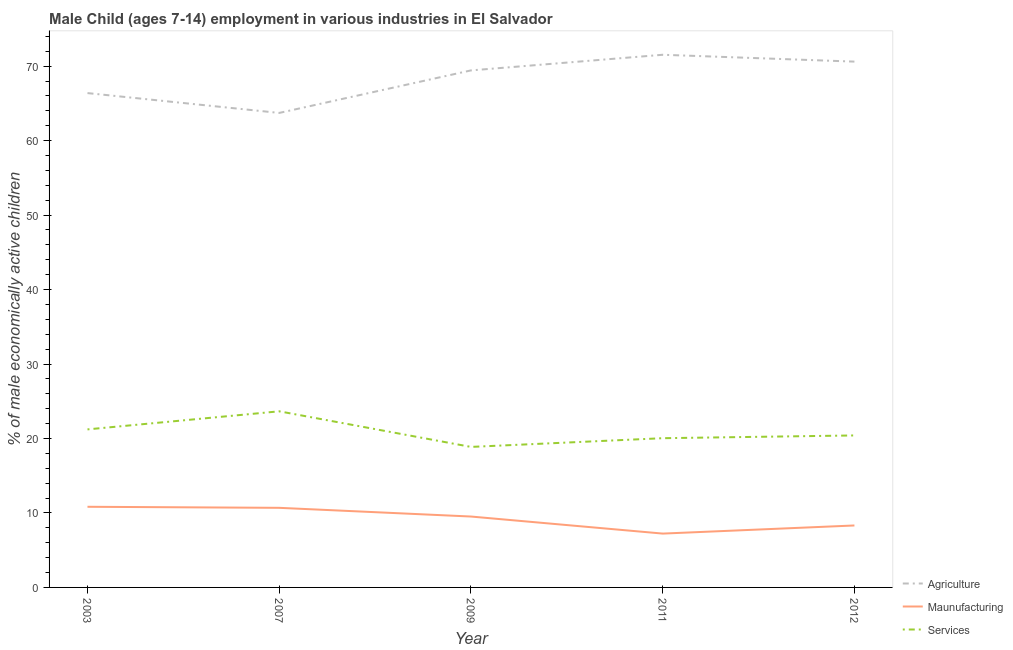How many different coloured lines are there?
Ensure brevity in your answer.  3. Does the line corresponding to percentage of economically active children in services intersect with the line corresponding to percentage of economically active children in manufacturing?
Provide a short and direct response. No. What is the percentage of economically active children in agriculture in 2009?
Your answer should be very brief. 69.43. Across all years, what is the maximum percentage of economically active children in manufacturing?
Your answer should be compact. 10.83. Across all years, what is the minimum percentage of economically active children in services?
Your answer should be very brief. 18.87. In which year was the percentage of economically active children in agriculture maximum?
Your answer should be very brief. 2011. What is the total percentage of economically active children in services in the graph?
Make the answer very short. 104.19. What is the difference between the percentage of economically active children in manufacturing in 2011 and that in 2012?
Offer a very short reply. -1.09. What is the difference between the percentage of economically active children in agriculture in 2012 and the percentage of economically active children in manufacturing in 2011?
Make the answer very short. 63.38. What is the average percentage of economically active children in services per year?
Give a very brief answer. 20.84. In the year 2011, what is the difference between the percentage of economically active children in services and percentage of economically active children in manufacturing?
Ensure brevity in your answer.  12.81. In how many years, is the percentage of economically active children in manufacturing greater than 12 %?
Keep it short and to the point. 0. What is the ratio of the percentage of economically active children in agriculture in 2003 to that in 2012?
Provide a succinct answer. 0.94. Is the difference between the percentage of economically active children in services in 2007 and 2011 greater than the difference between the percentage of economically active children in manufacturing in 2007 and 2011?
Give a very brief answer. Yes. What is the difference between the highest and the second highest percentage of economically active children in manufacturing?
Your answer should be compact. 0.14. What is the difference between the highest and the lowest percentage of economically active children in agriculture?
Keep it short and to the point. 7.81. In how many years, is the percentage of economically active children in services greater than the average percentage of economically active children in services taken over all years?
Your answer should be compact. 2. Does the percentage of economically active children in manufacturing monotonically increase over the years?
Your response must be concise. No. How many years are there in the graph?
Your response must be concise. 5. What is the difference between two consecutive major ticks on the Y-axis?
Provide a short and direct response. 10. Does the graph contain any zero values?
Your answer should be very brief. No. How many legend labels are there?
Your answer should be compact. 3. How are the legend labels stacked?
Your response must be concise. Vertical. What is the title of the graph?
Your response must be concise. Male Child (ages 7-14) employment in various industries in El Salvador. Does "Labor Market" appear as one of the legend labels in the graph?
Your answer should be very brief. No. What is the label or title of the Y-axis?
Make the answer very short. % of male economically active children. What is the % of male economically active children in Agriculture in 2003?
Ensure brevity in your answer.  66.38. What is the % of male economically active children in Maunufacturing in 2003?
Offer a very short reply. 10.83. What is the % of male economically active children of Services in 2003?
Offer a very short reply. 21.22. What is the % of male economically active children in Agriculture in 2007?
Provide a short and direct response. 63.72. What is the % of male economically active children in Maunufacturing in 2007?
Give a very brief answer. 10.69. What is the % of male economically active children in Services in 2007?
Provide a short and direct response. 23.65. What is the % of male economically active children in Agriculture in 2009?
Your answer should be very brief. 69.43. What is the % of male economically active children of Maunufacturing in 2009?
Provide a succinct answer. 9.52. What is the % of male economically active children of Services in 2009?
Give a very brief answer. 18.87. What is the % of male economically active children in Agriculture in 2011?
Your answer should be very brief. 71.53. What is the % of male economically active children in Maunufacturing in 2011?
Your answer should be compact. 7.23. What is the % of male economically active children of Services in 2011?
Your response must be concise. 20.04. What is the % of male economically active children in Agriculture in 2012?
Offer a terse response. 70.61. What is the % of male economically active children of Maunufacturing in 2012?
Offer a very short reply. 8.32. What is the % of male economically active children of Services in 2012?
Your answer should be very brief. 20.41. Across all years, what is the maximum % of male economically active children of Agriculture?
Make the answer very short. 71.53. Across all years, what is the maximum % of male economically active children of Maunufacturing?
Provide a succinct answer. 10.83. Across all years, what is the maximum % of male economically active children of Services?
Your answer should be very brief. 23.65. Across all years, what is the minimum % of male economically active children of Agriculture?
Give a very brief answer. 63.72. Across all years, what is the minimum % of male economically active children of Maunufacturing?
Keep it short and to the point. 7.23. Across all years, what is the minimum % of male economically active children of Services?
Your answer should be very brief. 18.87. What is the total % of male economically active children of Agriculture in the graph?
Make the answer very short. 341.67. What is the total % of male economically active children of Maunufacturing in the graph?
Your response must be concise. 46.59. What is the total % of male economically active children of Services in the graph?
Make the answer very short. 104.19. What is the difference between the % of male economically active children of Agriculture in 2003 and that in 2007?
Offer a very short reply. 2.66. What is the difference between the % of male economically active children of Maunufacturing in 2003 and that in 2007?
Make the answer very short. 0.14. What is the difference between the % of male economically active children of Services in 2003 and that in 2007?
Make the answer very short. -2.43. What is the difference between the % of male economically active children of Agriculture in 2003 and that in 2009?
Provide a short and direct response. -3.05. What is the difference between the % of male economically active children in Maunufacturing in 2003 and that in 2009?
Provide a short and direct response. 1.31. What is the difference between the % of male economically active children of Services in 2003 and that in 2009?
Give a very brief answer. 2.35. What is the difference between the % of male economically active children of Agriculture in 2003 and that in 2011?
Provide a short and direct response. -5.15. What is the difference between the % of male economically active children of Maunufacturing in 2003 and that in 2011?
Provide a succinct answer. 3.6. What is the difference between the % of male economically active children of Services in 2003 and that in 2011?
Offer a terse response. 1.18. What is the difference between the % of male economically active children in Agriculture in 2003 and that in 2012?
Your response must be concise. -4.23. What is the difference between the % of male economically active children of Maunufacturing in 2003 and that in 2012?
Make the answer very short. 2.51. What is the difference between the % of male economically active children of Services in 2003 and that in 2012?
Provide a succinct answer. 0.81. What is the difference between the % of male economically active children in Agriculture in 2007 and that in 2009?
Keep it short and to the point. -5.71. What is the difference between the % of male economically active children in Maunufacturing in 2007 and that in 2009?
Provide a short and direct response. 1.17. What is the difference between the % of male economically active children of Services in 2007 and that in 2009?
Ensure brevity in your answer.  4.78. What is the difference between the % of male economically active children in Agriculture in 2007 and that in 2011?
Offer a very short reply. -7.81. What is the difference between the % of male economically active children in Maunufacturing in 2007 and that in 2011?
Your response must be concise. 3.46. What is the difference between the % of male economically active children of Services in 2007 and that in 2011?
Your answer should be compact. 3.61. What is the difference between the % of male economically active children of Agriculture in 2007 and that in 2012?
Your answer should be compact. -6.89. What is the difference between the % of male economically active children of Maunufacturing in 2007 and that in 2012?
Provide a succinct answer. 2.37. What is the difference between the % of male economically active children in Services in 2007 and that in 2012?
Offer a very short reply. 3.24. What is the difference between the % of male economically active children of Agriculture in 2009 and that in 2011?
Make the answer very short. -2.1. What is the difference between the % of male economically active children of Maunufacturing in 2009 and that in 2011?
Keep it short and to the point. 2.29. What is the difference between the % of male economically active children of Services in 2009 and that in 2011?
Provide a succinct answer. -1.17. What is the difference between the % of male economically active children in Agriculture in 2009 and that in 2012?
Provide a succinct answer. -1.18. What is the difference between the % of male economically active children in Services in 2009 and that in 2012?
Provide a short and direct response. -1.54. What is the difference between the % of male economically active children of Agriculture in 2011 and that in 2012?
Ensure brevity in your answer.  0.92. What is the difference between the % of male economically active children of Maunufacturing in 2011 and that in 2012?
Keep it short and to the point. -1.09. What is the difference between the % of male economically active children of Services in 2011 and that in 2012?
Make the answer very short. -0.37. What is the difference between the % of male economically active children of Agriculture in 2003 and the % of male economically active children of Maunufacturing in 2007?
Give a very brief answer. 55.69. What is the difference between the % of male economically active children of Agriculture in 2003 and the % of male economically active children of Services in 2007?
Provide a short and direct response. 42.73. What is the difference between the % of male economically active children in Maunufacturing in 2003 and the % of male economically active children in Services in 2007?
Offer a very short reply. -12.82. What is the difference between the % of male economically active children of Agriculture in 2003 and the % of male economically active children of Maunufacturing in 2009?
Offer a terse response. 56.86. What is the difference between the % of male economically active children of Agriculture in 2003 and the % of male economically active children of Services in 2009?
Ensure brevity in your answer.  47.51. What is the difference between the % of male economically active children of Maunufacturing in 2003 and the % of male economically active children of Services in 2009?
Offer a very short reply. -8.04. What is the difference between the % of male economically active children in Agriculture in 2003 and the % of male economically active children in Maunufacturing in 2011?
Your answer should be very brief. 59.15. What is the difference between the % of male economically active children of Agriculture in 2003 and the % of male economically active children of Services in 2011?
Your response must be concise. 46.34. What is the difference between the % of male economically active children in Maunufacturing in 2003 and the % of male economically active children in Services in 2011?
Your response must be concise. -9.21. What is the difference between the % of male economically active children of Agriculture in 2003 and the % of male economically active children of Maunufacturing in 2012?
Give a very brief answer. 58.06. What is the difference between the % of male economically active children of Agriculture in 2003 and the % of male economically active children of Services in 2012?
Your response must be concise. 45.97. What is the difference between the % of male economically active children in Maunufacturing in 2003 and the % of male economically active children in Services in 2012?
Offer a very short reply. -9.58. What is the difference between the % of male economically active children of Agriculture in 2007 and the % of male economically active children of Maunufacturing in 2009?
Make the answer very short. 54.2. What is the difference between the % of male economically active children of Agriculture in 2007 and the % of male economically active children of Services in 2009?
Provide a short and direct response. 44.85. What is the difference between the % of male economically active children in Maunufacturing in 2007 and the % of male economically active children in Services in 2009?
Provide a succinct answer. -8.18. What is the difference between the % of male economically active children in Agriculture in 2007 and the % of male economically active children in Maunufacturing in 2011?
Your answer should be compact. 56.49. What is the difference between the % of male economically active children of Agriculture in 2007 and the % of male economically active children of Services in 2011?
Provide a short and direct response. 43.68. What is the difference between the % of male economically active children of Maunufacturing in 2007 and the % of male economically active children of Services in 2011?
Make the answer very short. -9.35. What is the difference between the % of male economically active children in Agriculture in 2007 and the % of male economically active children in Maunufacturing in 2012?
Make the answer very short. 55.4. What is the difference between the % of male economically active children of Agriculture in 2007 and the % of male economically active children of Services in 2012?
Ensure brevity in your answer.  43.31. What is the difference between the % of male economically active children in Maunufacturing in 2007 and the % of male economically active children in Services in 2012?
Your answer should be compact. -9.72. What is the difference between the % of male economically active children in Agriculture in 2009 and the % of male economically active children in Maunufacturing in 2011?
Keep it short and to the point. 62.2. What is the difference between the % of male economically active children of Agriculture in 2009 and the % of male economically active children of Services in 2011?
Offer a terse response. 49.39. What is the difference between the % of male economically active children of Maunufacturing in 2009 and the % of male economically active children of Services in 2011?
Ensure brevity in your answer.  -10.52. What is the difference between the % of male economically active children of Agriculture in 2009 and the % of male economically active children of Maunufacturing in 2012?
Offer a terse response. 61.11. What is the difference between the % of male economically active children in Agriculture in 2009 and the % of male economically active children in Services in 2012?
Offer a very short reply. 49.02. What is the difference between the % of male economically active children of Maunufacturing in 2009 and the % of male economically active children of Services in 2012?
Ensure brevity in your answer.  -10.89. What is the difference between the % of male economically active children of Agriculture in 2011 and the % of male economically active children of Maunufacturing in 2012?
Offer a very short reply. 63.21. What is the difference between the % of male economically active children of Agriculture in 2011 and the % of male economically active children of Services in 2012?
Offer a terse response. 51.12. What is the difference between the % of male economically active children in Maunufacturing in 2011 and the % of male economically active children in Services in 2012?
Provide a short and direct response. -13.18. What is the average % of male economically active children of Agriculture per year?
Your answer should be very brief. 68.33. What is the average % of male economically active children of Maunufacturing per year?
Your answer should be compact. 9.32. What is the average % of male economically active children in Services per year?
Provide a short and direct response. 20.84. In the year 2003, what is the difference between the % of male economically active children in Agriculture and % of male economically active children in Maunufacturing?
Offer a terse response. 55.55. In the year 2003, what is the difference between the % of male economically active children of Agriculture and % of male economically active children of Services?
Your response must be concise. 45.16. In the year 2003, what is the difference between the % of male economically active children of Maunufacturing and % of male economically active children of Services?
Your response must be concise. -10.39. In the year 2007, what is the difference between the % of male economically active children in Agriculture and % of male economically active children in Maunufacturing?
Offer a terse response. 53.03. In the year 2007, what is the difference between the % of male economically active children of Agriculture and % of male economically active children of Services?
Offer a terse response. 40.07. In the year 2007, what is the difference between the % of male economically active children of Maunufacturing and % of male economically active children of Services?
Make the answer very short. -12.96. In the year 2009, what is the difference between the % of male economically active children in Agriculture and % of male economically active children in Maunufacturing?
Your answer should be compact. 59.91. In the year 2009, what is the difference between the % of male economically active children in Agriculture and % of male economically active children in Services?
Provide a succinct answer. 50.56. In the year 2009, what is the difference between the % of male economically active children of Maunufacturing and % of male economically active children of Services?
Ensure brevity in your answer.  -9.35. In the year 2011, what is the difference between the % of male economically active children of Agriculture and % of male economically active children of Maunufacturing?
Provide a short and direct response. 64.3. In the year 2011, what is the difference between the % of male economically active children in Agriculture and % of male economically active children in Services?
Your response must be concise. 51.49. In the year 2011, what is the difference between the % of male economically active children in Maunufacturing and % of male economically active children in Services?
Give a very brief answer. -12.81. In the year 2012, what is the difference between the % of male economically active children in Agriculture and % of male economically active children in Maunufacturing?
Offer a terse response. 62.29. In the year 2012, what is the difference between the % of male economically active children of Agriculture and % of male economically active children of Services?
Keep it short and to the point. 50.2. In the year 2012, what is the difference between the % of male economically active children in Maunufacturing and % of male economically active children in Services?
Offer a very short reply. -12.09. What is the ratio of the % of male economically active children of Agriculture in 2003 to that in 2007?
Your answer should be compact. 1.04. What is the ratio of the % of male economically active children of Maunufacturing in 2003 to that in 2007?
Offer a very short reply. 1.01. What is the ratio of the % of male economically active children in Services in 2003 to that in 2007?
Your response must be concise. 0.9. What is the ratio of the % of male economically active children in Agriculture in 2003 to that in 2009?
Provide a succinct answer. 0.96. What is the ratio of the % of male economically active children of Maunufacturing in 2003 to that in 2009?
Ensure brevity in your answer.  1.14. What is the ratio of the % of male economically active children in Services in 2003 to that in 2009?
Your answer should be very brief. 1.12. What is the ratio of the % of male economically active children of Agriculture in 2003 to that in 2011?
Offer a terse response. 0.93. What is the ratio of the % of male economically active children of Maunufacturing in 2003 to that in 2011?
Provide a succinct answer. 1.5. What is the ratio of the % of male economically active children of Services in 2003 to that in 2011?
Provide a succinct answer. 1.06. What is the ratio of the % of male economically active children of Agriculture in 2003 to that in 2012?
Your answer should be compact. 0.94. What is the ratio of the % of male economically active children in Maunufacturing in 2003 to that in 2012?
Offer a terse response. 1.3. What is the ratio of the % of male economically active children in Services in 2003 to that in 2012?
Give a very brief answer. 1.04. What is the ratio of the % of male economically active children in Agriculture in 2007 to that in 2009?
Provide a succinct answer. 0.92. What is the ratio of the % of male economically active children of Maunufacturing in 2007 to that in 2009?
Your answer should be compact. 1.12. What is the ratio of the % of male economically active children in Services in 2007 to that in 2009?
Provide a succinct answer. 1.25. What is the ratio of the % of male economically active children in Agriculture in 2007 to that in 2011?
Offer a terse response. 0.89. What is the ratio of the % of male economically active children of Maunufacturing in 2007 to that in 2011?
Make the answer very short. 1.48. What is the ratio of the % of male economically active children in Services in 2007 to that in 2011?
Provide a short and direct response. 1.18. What is the ratio of the % of male economically active children of Agriculture in 2007 to that in 2012?
Your response must be concise. 0.9. What is the ratio of the % of male economically active children in Maunufacturing in 2007 to that in 2012?
Your answer should be compact. 1.28. What is the ratio of the % of male economically active children of Services in 2007 to that in 2012?
Give a very brief answer. 1.16. What is the ratio of the % of male economically active children of Agriculture in 2009 to that in 2011?
Offer a very short reply. 0.97. What is the ratio of the % of male economically active children in Maunufacturing in 2009 to that in 2011?
Offer a terse response. 1.32. What is the ratio of the % of male economically active children of Services in 2009 to that in 2011?
Provide a short and direct response. 0.94. What is the ratio of the % of male economically active children in Agriculture in 2009 to that in 2012?
Your answer should be compact. 0.98. What is the ratio of the % of male economically active children in Maunufacturing in 2009 to that in 2012?
Offer a very short reply. 1.14. What is the ratio of the % of male economically active children in Services in 2009 to that in 2012?
Give a very brief answer. 0.92. What is the ratio of the % of male economically active children of Agriculture in 2011 to that in 2012?
Your response must be concise. 1.01. What is the ratio of the % of male economically active children of Maunufacturing in 2011 to that in 2012?
Provide a succinct answer. 0.87. What is the ratio of the % of male economically active children in Services in 2011 to that in 2012?
Your answer should be very brief. 0.98. What is the difference between the highest and the second highest % of male economically active children in Agriculture?
Provide a succinct answer. 0.92. What is the difference between the highest and the second highest % of male economically active children in Maunufacturing?
Provide a short and direct response. 0.14. What is the difference between the highest and the second highest % of male economically active children of Services?
Keep it short and to the point. 2.43. What is the difference between the highest and the lowest % of male economically active children of Agriculture?
Your response must be concise. 7.81. What is the difference between the highest and the lowest % of male economically active children in Maunufacturing?
Make the answer very short. 3.6. What is the difference between the highest and the lowest % of male economically active children in Services?
Keep it short and to the point. 4.78. 